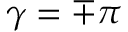<formula> <loc_0><loc_0><loc_500><loc_500>\gamma = \mp \pi</formula> 